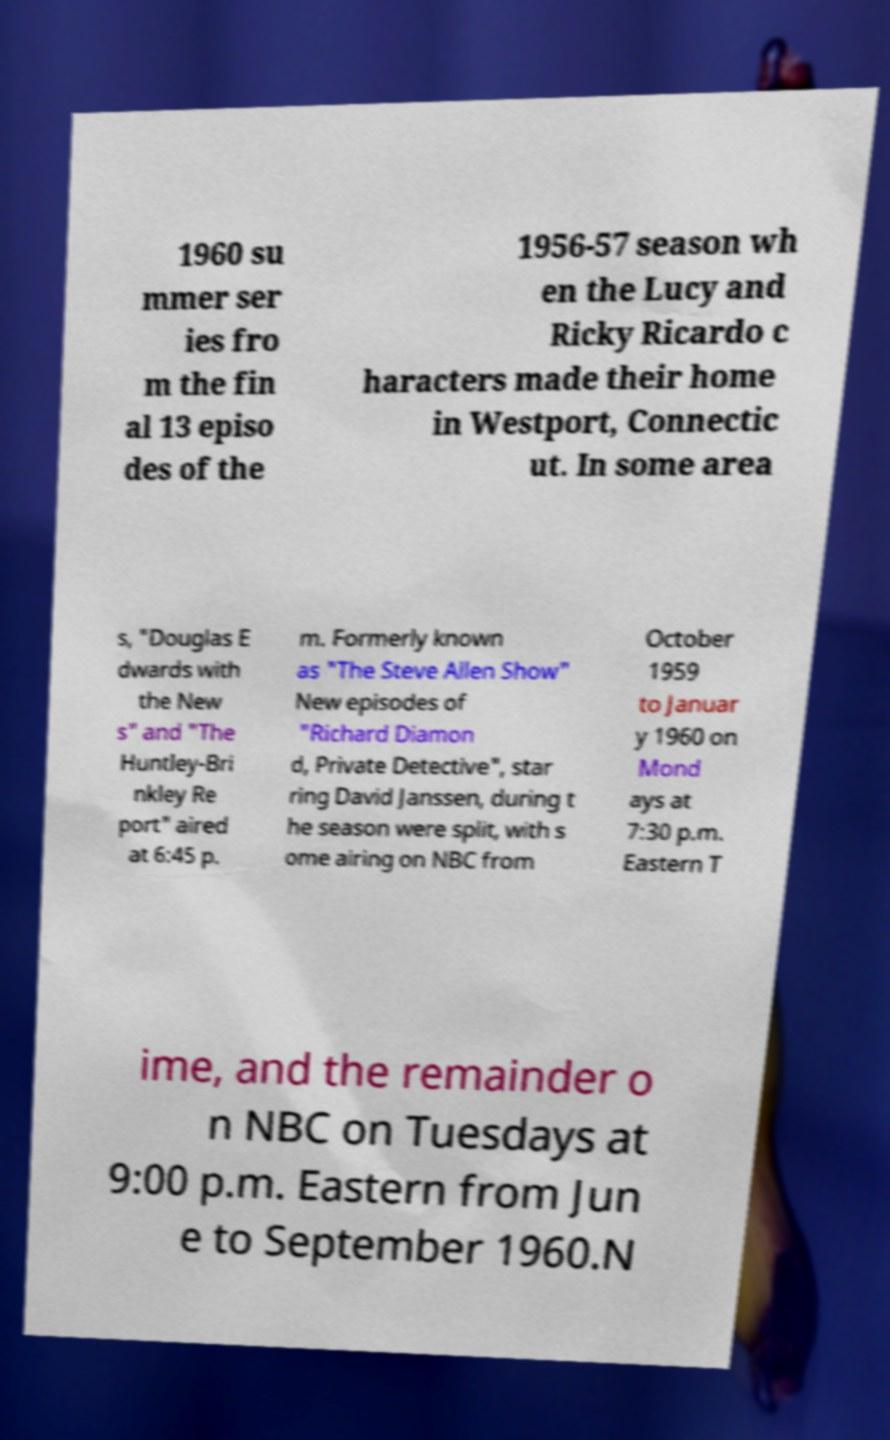For documentation purposes, I need the text within this image transcribed. Could you provide that? 1960 su mmer ser ies fro m the fin al 13 episo des of the 1956-57 season wh en the Lucy and Ricky Ricardo c haracters made their home in Westport, Connectic ut. In some area s, "Douglas E dwards with the New s" and "The Huntley-Bri nkley Re port" aired at 6:45 p. m. Formerly known as "The Steve Allen Show" New episodes of "Richard Diamon d, Private Detective", star ring David Janssen, during t he season were split, with s ome airing on NBC from October 1959 to Januar y 1960 on Mond ays at 7:30 p.m. Eastern T ime, and the remainder o n NBC on Tuesdays at 9:00 p.m. Eastern from Jun e to September 1960.N 